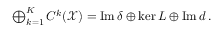Convert formula to latex. <formula><loc_0><loc_0><loc_500><loc_500>\begin{array} { r } { \bigoplus _ { k = 1 } ^ { K } C ^ { k } ( \mathcal { X } ) = I m \, \delta \oplus k e r \, L \oplus I m \, d \, . } \end{array}</formula> 